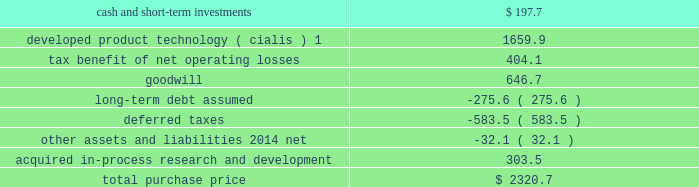Icos corporation on january 29 , 2007 , we acquired all of the outstanding common stock of icos corporation ( icos ) , our partner in the lilly icos llc joint venture for the manufacture and sale of cialis for the treatment of erectile dysfunction .
The acquisition brought the full value of cialis to us and enabled us to realize operational effi ciencies in the further development , marketing , and selling of this product .
The aggregate cash purchase price of approximately $ 2.3 bil- lion was fi nanced through borrowings .
The acquisition has been accounted for as a business combination under the purchase method of accounting , resulting in goodwill of $ 646.7 million .
No portion of this goodwill was deductible for tax purposes .
We determined the following estimated fair values for the assets acquired and liabilities assumed as of the date of acquisition .
Estimated fair value at january 29 , 2007 .
1this intangible asset will be amortized over the remaining expected patent lives of cialis in each country ; patent expiry dates range from 2015 to 2017 .
New indications for and formulations of the cialis compound in clinical testing at the time of the acquisition represented approximately 48 percent of the estimated fair value of the acquired ipr&d .
The remaining value of acquired ipr&d represented several other products in development , with no one asset comprising a signifi cant por- tion of this value .
The discount rate we used in valuing the acquired ipr&d projects was 20 percent , and the charge for acquired ipr&d of $ 303.5 million recorded in the fi rst quarter of 2007 was not deductible for tax purposes .
Other acquisitions during the second quarter of 2007 , we acquired all of the outstanding stock of both hypnion , inc .
( hypnion ) , a privately held neuroscience drug discovery company focused on sleep disorders , and ivy animal health , inc .
( ivy ) , a privately held applied research and pharmaceutical product development company focused on the animal health industry , for $ 445.0 million in cash .
The acquisition of hypnion provided us with a broader and more substantive presence in the area of sleep disorder research and ownership of hy10275 , a novel phase ii compound with a dual mechanism of action aimed at promoting better sleep onset and sleep maintenance .
This was hypnion 2019s only signifi cant asset .
For this acquisi- tion , we recorded an acquired ipr&d charge of $ 291.1 million , which was not deductible for tax purposes .
Because hypnion was a development-stage company , the transaction was accounted for as an acquisition of assets rather than as a business combination and , therefore , goodwill was not recorded .
The acquisition of ivy provides us with products that complement those of our animal health business .
This acquisition has been accounted for as a business combination under the purchase method of accounting .
We allocated $ 88.7 million of the purchase price to other identifi able intangible assets , primarily related to marketed products , $ 37.0 million to acquired ipr&d , and $ 25.0 million to goodwill .
The other identifi able intangible assets are being amortized over their estimated remaining useful lives of 10 to 20 years .
The $ 37.0 million allocated to acquired ipr&d was charged to expense in the second quarter of 2007 .
Goodwill resulting from this acquisition was fully allocated to the animal health business segment .
The amount allocated to each of the intangible assets acquired , including goodwill of $ 25.0 million and the acquired ipr&d of $ 37.0 million , was deductible for tax purposes .
Product acquisitions in june 2008 , we entered into a licensing and development agreement with transpharma medical ltd .
( trans- pharma ) to acquire rights to its product and related drug delivery system for the treatment of osteoporosis .
The product , which is administered transdermally using transpharma 2019s proprietary technology , was in phase ii clinical testing , and had no alternative future use .
Under the arrangement , we also gained non-exclusive access to trans- pharma 2019s viaderm drug delivery system for the product .
As with many development-phase products , launch of the .
At january 29 , 2007 what was the percent of the estimated fair value of the goodwill to the total purchase price? 
Rationale: the total purchase price was made of 27.9% of the estimated fair value of the goodwill
Computations: (646.7 / 2320.7)
Answer: 0.27867. 